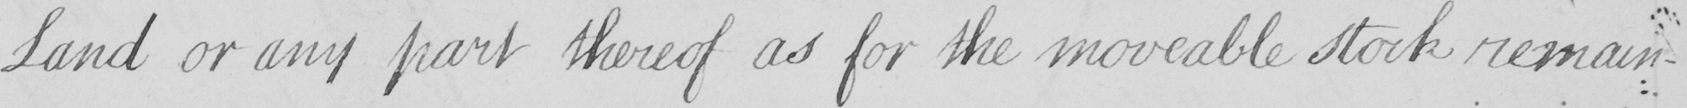Can you read and transcribe this handwriting? Land or any part thereof as for the moveable stock remain- 